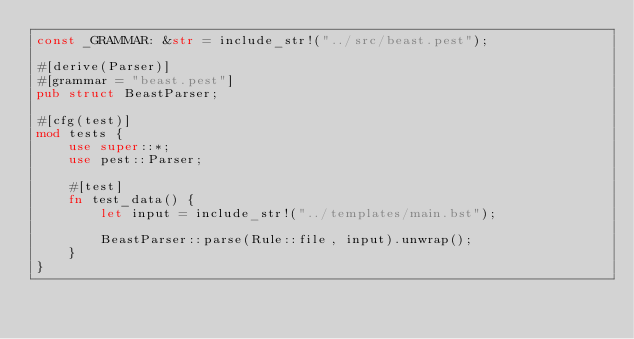Convert code to text. <code><loc_0><loc_0><loc_500><loc_500><_Rust_>const _GRAMMAR: &str = include_str!("../src/beast.pest");

#[derive(Parser)]
#[grammar = "beast.pest"]
pub struct BeastParser;

#[cfg(test)]
mod tests {
    use super::*;
    use pest::Parser;

    #[test]
    fn test_data() {
        let input = include_str!("../templates/main.bst");

        BeastParser::parse(Rule::file, input).unwrap();
    }
}
</code> 